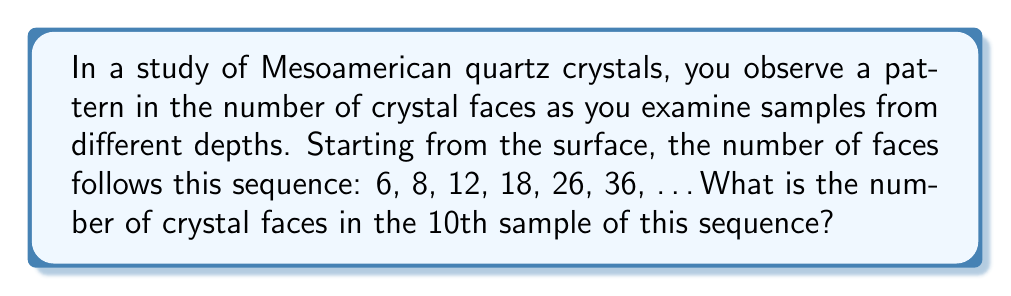What is the answer to this math problem? Let's approach this step-by-step:

1) First, let's examine the differences between consecutive terms:
   6 to 8: difference of 2
   8 to 12: difference of 4
   12 to 18: difference of 6
   18 to 26: difference of 8
   26 to 36: difference of 10

2) We can see that the differences are increasing by 2 each time: 2, 4, 6, 8, 10, ...

3) This suggests that the sequence is a quadratic sequence, where the second differences are constant.

4) The general form of a quadratic sequence is:
   $$a_n = an^2 + bn + c$$
   where $n$ is the position in the sequence (starting from 0), and $a$, $b$, and $c$ are constants we need to determine.

5) We can use the first three terms to set up a system of equations:
   $$6 = a(0)^2 + b(0) + c$$
   $$8 = a(1)^2 + b(1) + c$$
   $$12 = a(2)^2 + b(2) + c$$

6) Simplifying:
   $$6 = c$$
   $$8 = a + b + 6$$
   $$12 = 4a + 2b + 6$$

7) From the first equation, $c = 6$. Subtracting the second equation from the third:
   $$4 = 3a + b$$

8) From the second equation:
   $$2 = a + b$$

9) Subtracting these last two equations:
   $$2 = 2a$$
   $$a = 1$$

10) Substituting back:
    $$2 = 1 + b$$
    $$b = 1$$

11) Therefore, our sequence is defined by:
    $$a_n = n^2 + n + 6$$

12) For the 10th sample, $n = 9$ (remember, we started counting at 0), so:
    $$a_9 = 9^2 + 9 + 6 = 81 + 9 + 6 = 96$$
Answer: 96 